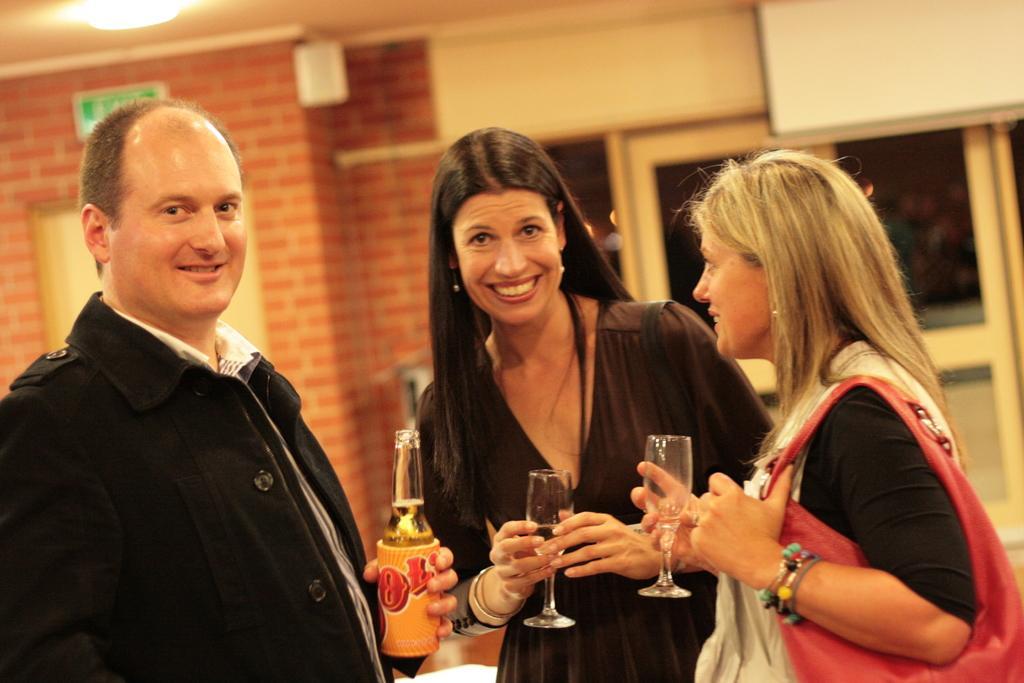Can you describe this image briefly? In the picture we can see a man and two women are standing, women are holding a glass with wine and man is holding a wine bottle and they are smiling and in the background, we can see a wall which is designed as a brick wall and besides we can see a window with a glass to it. 